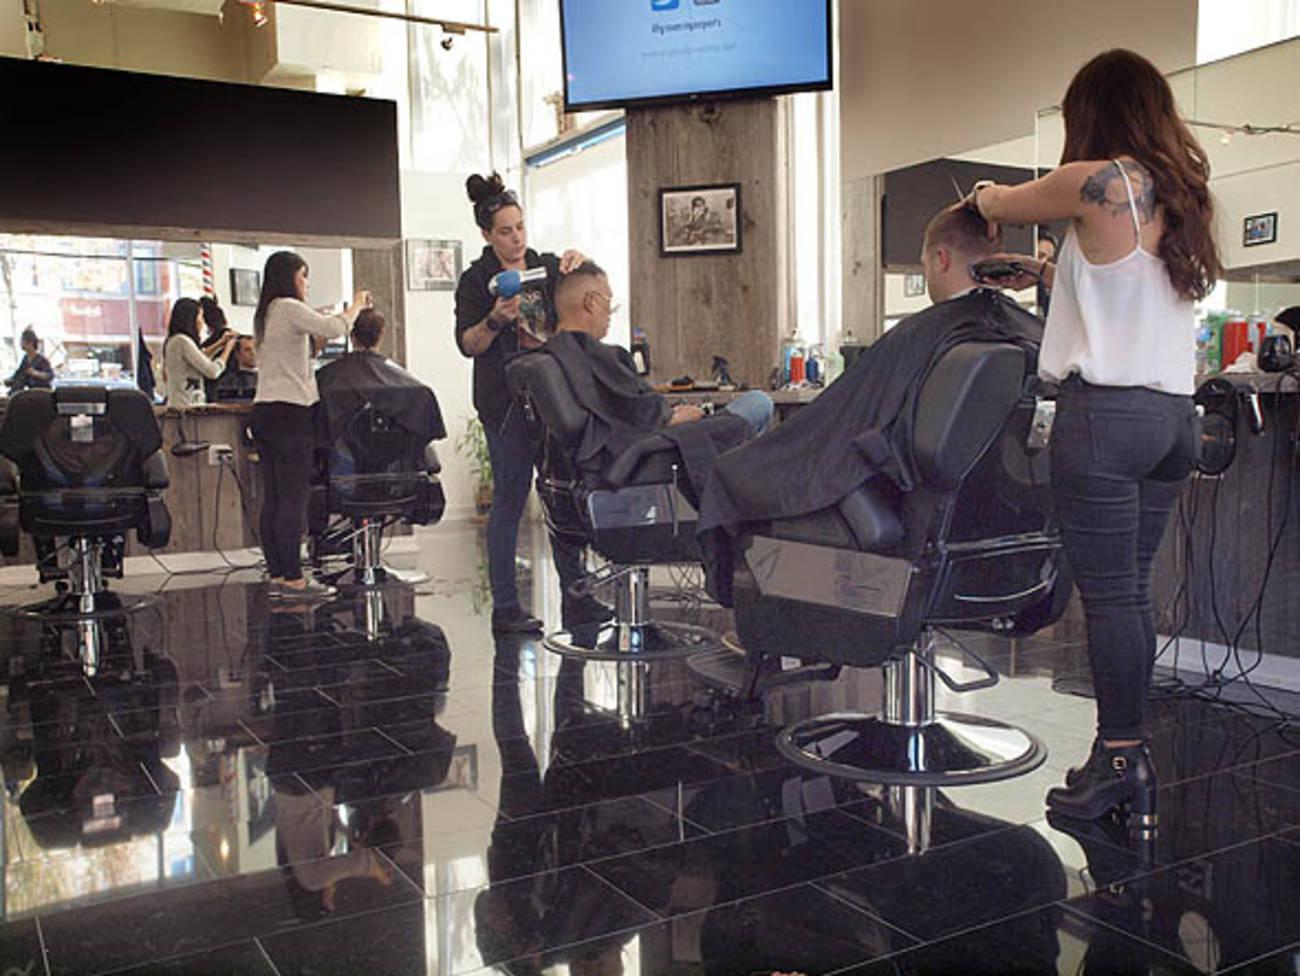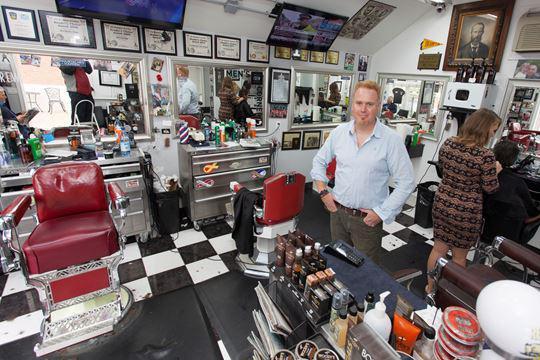The first image is the image on the left, the second image is the image on the right. For the images displayed, is the sentence "THere are exactly two people in the image on the left." factually correct? Answer yes or no. No. 